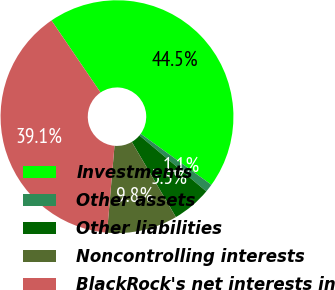Convert chart to OTSL. <chart><loc_0><loc_0><loc_500><loc_500><pie_chart><fcel>Investments<fcel>Other assets<fcel>Other liabilities<fcel>Noncontrolling interests<fcel>BlackRock's net interests in<nl><fcel>44.46%<fcel>1.14%<fcel>5.47%<fcel>9.81%<fcel>39.12%<nl></chart> 